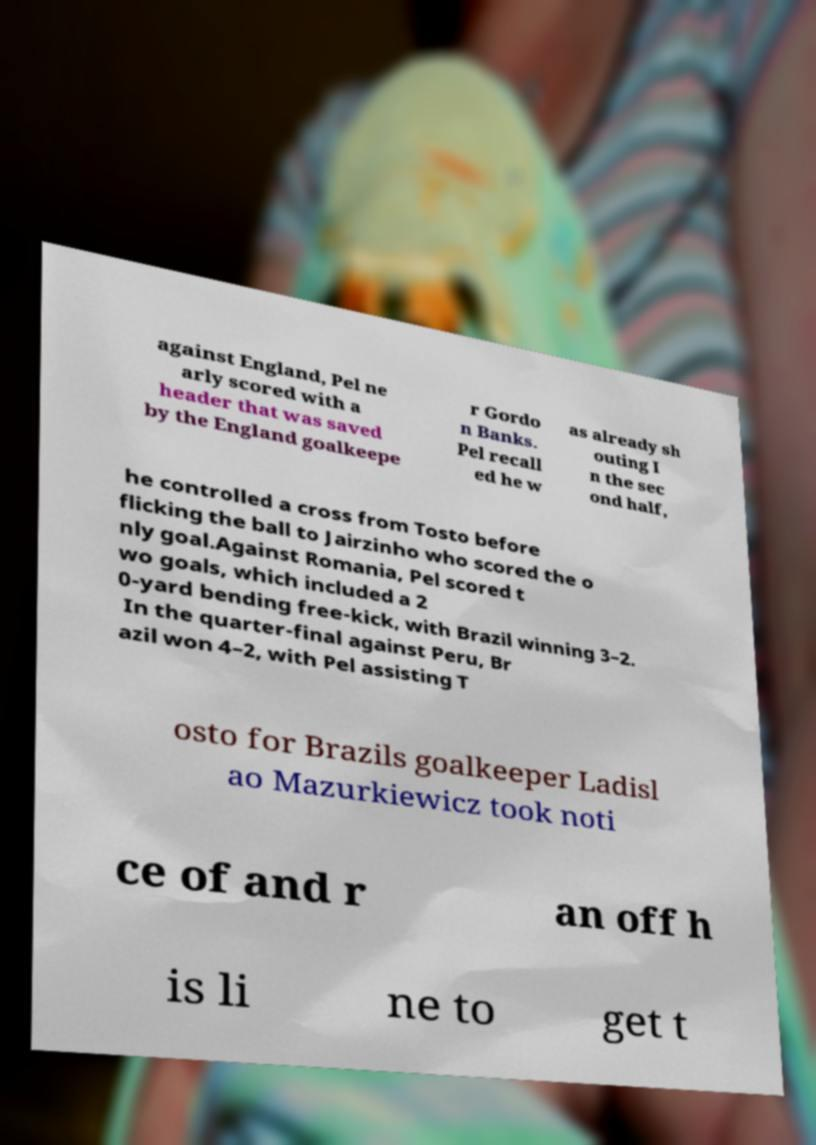Could you extract and type out the text from this image? against England, Pel ne arly scored with a header that was saved by the England goalkeepe r Gordo n Banks. Pel recall ed he w as already sh outing I n the sec ond half, he controlled a cross from Tosto before flicking the ball to Jairzinho who scored the o nly goal.Against Romania, Pel scored t wo goals, which included a 2 0-yard bending free-kick, with Brazil winning 3–2. In the quarter-final against Peru, Br azil won 4–2, with Pel assisting T osto for Brazils goalkeeper Ladisl ao Mazurkiewicz took noti ce of and r an off h is li ne to get t 